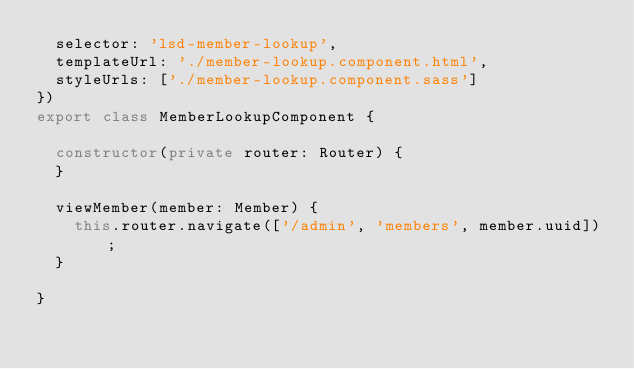Convert code to text. <code><loc_0><loc_0><loc_500><loc_500><_TypeScript_>  selector: 'lsd-member-lookup',
  templateUrl: './member-lookup.component.html',
  styleUrls: ['./member-lookup.component.sass']
})
export class MemberLookupComponent {

  constructor(private router: Router) {
  }

  viewMember(member: Member) {
    this.router.navigate(['/admin', 'members', member.uuid]);
  }

}
</code> 